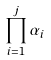<formula> <loc_0><loc_0><loc_500><loc_500>\prod _ { i = 1 } ^ { j } \alpha _ { i }</formula> 